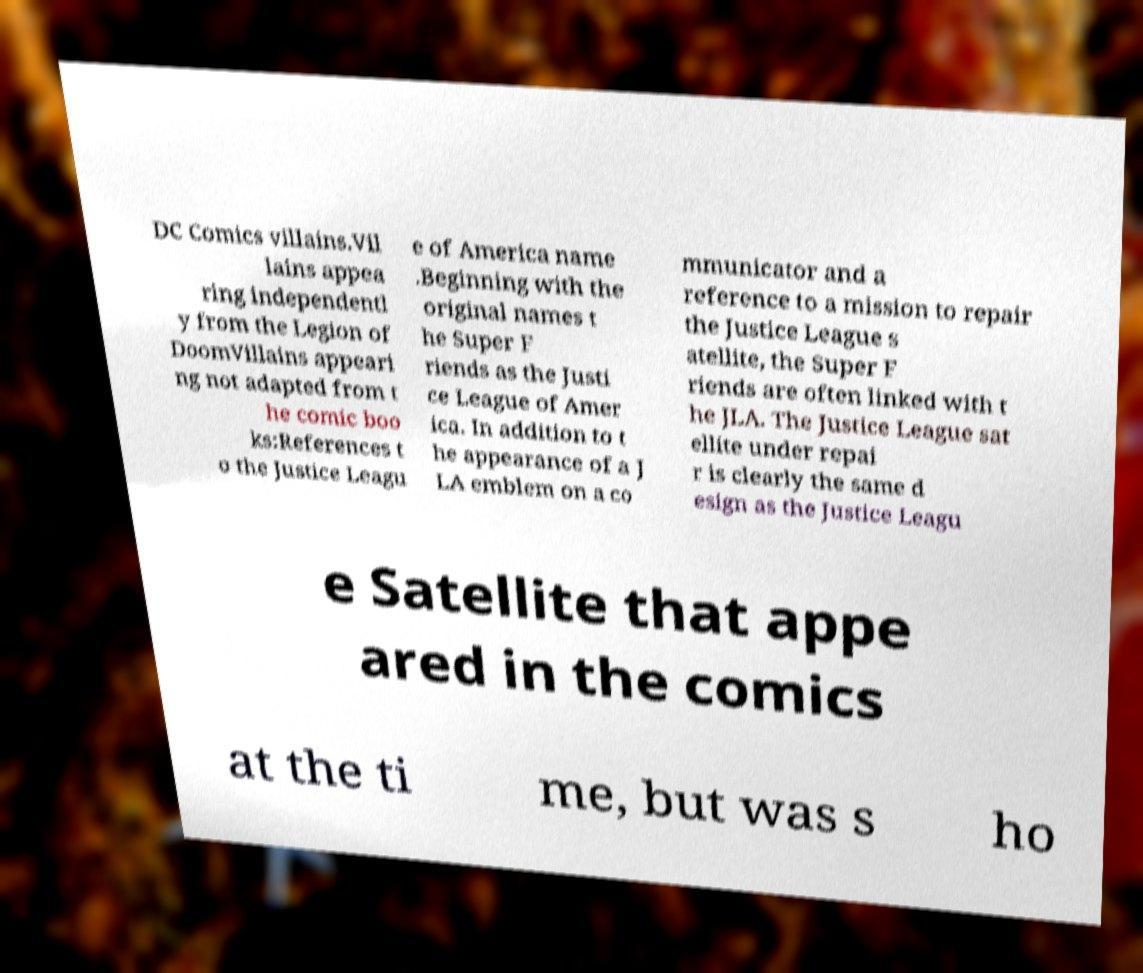What messages or text are displayed in this image? I need them in a readable, typed format. DC Comics villains.Vil lains appea ring independentl y from the Legion of DoomVillains appeari ng not adapted from t he comic boo ks:References t o the Justice Leagu e of America name .Beginning with the original names t he Super F riends as the Justi ce League of Amer ica. In addition to t he appearance of a J LA emblem on a co mmunicator and a reference to a mission to repair the Justice League s atellite, the Super F riends are often linked with t he JLA. The Justice League sat ellite under repai r is clearly the same d esign as the Justice Leagu e Satellite that appe ared in the comics at the ti me, but was s ho 